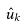Convert formula to latex. <formula><loc_0><loc_0><loc_500><loc_500>\hat { u } _ { k }</formula> 